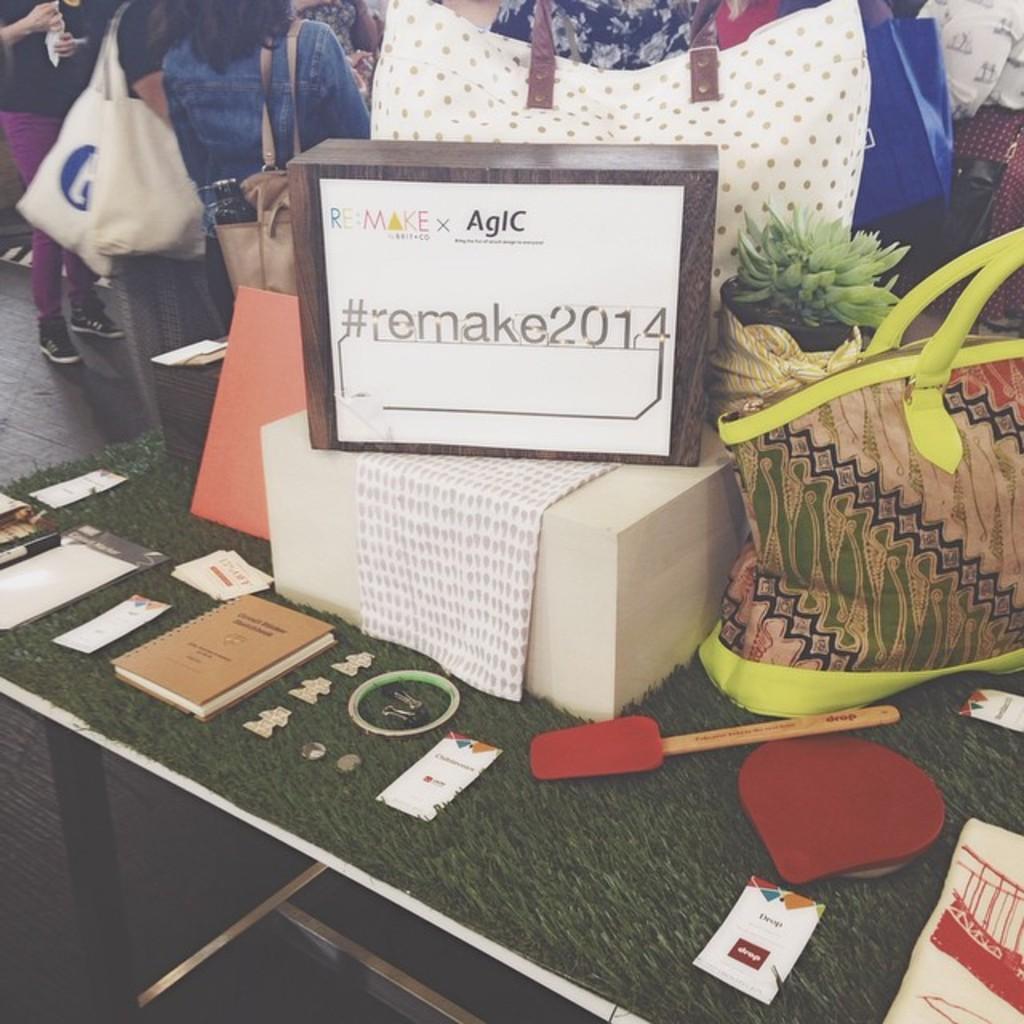Please provide a concise description of this image. In this image we can see the table, on the table there are bags, boxes, cloth, bats, papers and few objects. In the background, we can see the people standing on the floor. 